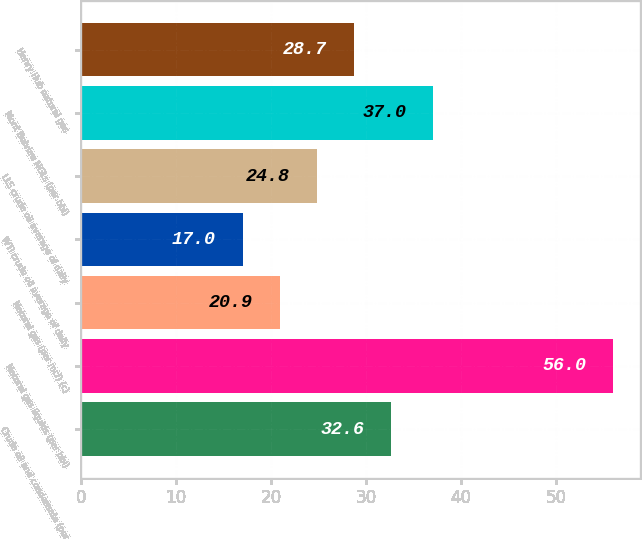Convert chart to OTSL. <chart><loc_0><loc_0><loc_500><loc_500><bar_chart><fcel>Crude oil and condensate (per<fcel>Natural gas liquids (per bbl)<fcel>Natural gas (per mcf) (c)<fcel>WTI crude oil average of daily<fcel>LLS crude oil average of daily<fcel>Mont Belvieu NGLs (per bbl)<fcel>Henry Hub natural gas<nl><fcel>32.6<fcel>56<fcel>20.9<fcel>17<fcel>24.8<fcel>37<fcel>28.7<nl></chart> 